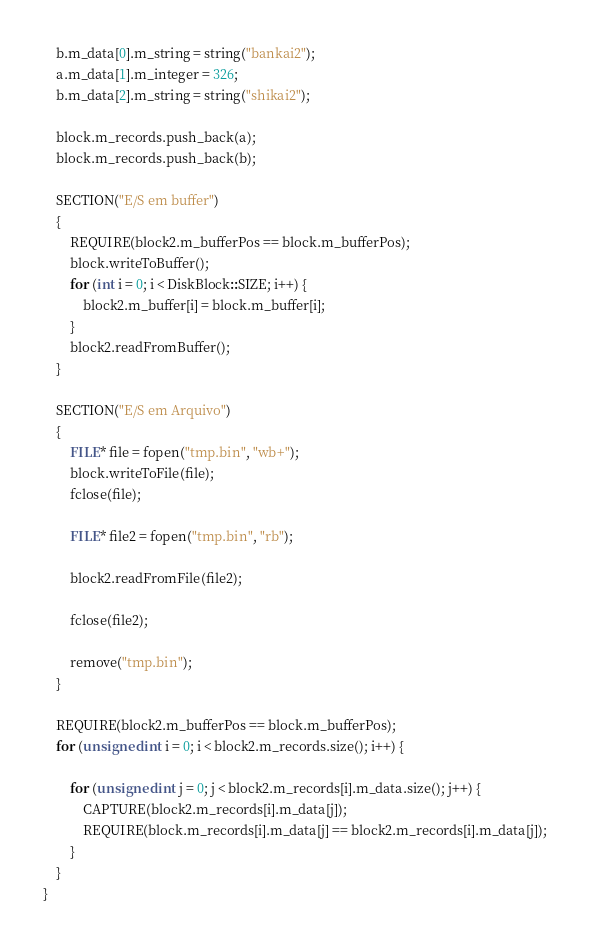<code> <loc_0><loc_0><loc_500><loc_500><_C++_>    b.m_data[0].m_string = string("bankai2");
    a.m_data[1].m_integer = 326;
    b.m_data[2].m_string = string("shikai2");

    block.m_records.push_back(a);
    block.m_records.push_back(b);

    SECTION("E/S em buffer")
    {
        REQUIRE(block2.m_bufferPos == block.m_bufferPos);
        block.writeToBuffer();
        for (int i = 0; i < DiskBlock::SIZE; i++) {
            block2.m_buffer[i] = block.m_buffer[i];
        }
        block2.readFromBuffer();
    }

    SECTION("E/S em Arquivo")
    {
        FILE* file = fopen("tmp.bin", "wb+");
        block.writeToFile(file);
        fclose(file);

        FILE* file2 = fopen("tmp.bin", "rb");

        block2.readFromFile(file2);

        fclose(file2);

        remove("tmp.bin");
    }

    REQUIRE(block2.m_bufferPos == block.m_bufferPos);
    for (unsigned int i = 0; i < block2.m_records.size(); i++) {

        for (unsigned int j = 0; j < block2.m_records[i].m_data.size(); j++) {
            CAPTURE(block2.m_records[i].m_data[j]);
            REQUIRE(block.m_records[i].m_data[j] == block2.m_records[i].m_data[j]);
        }
    }
}
</code> 